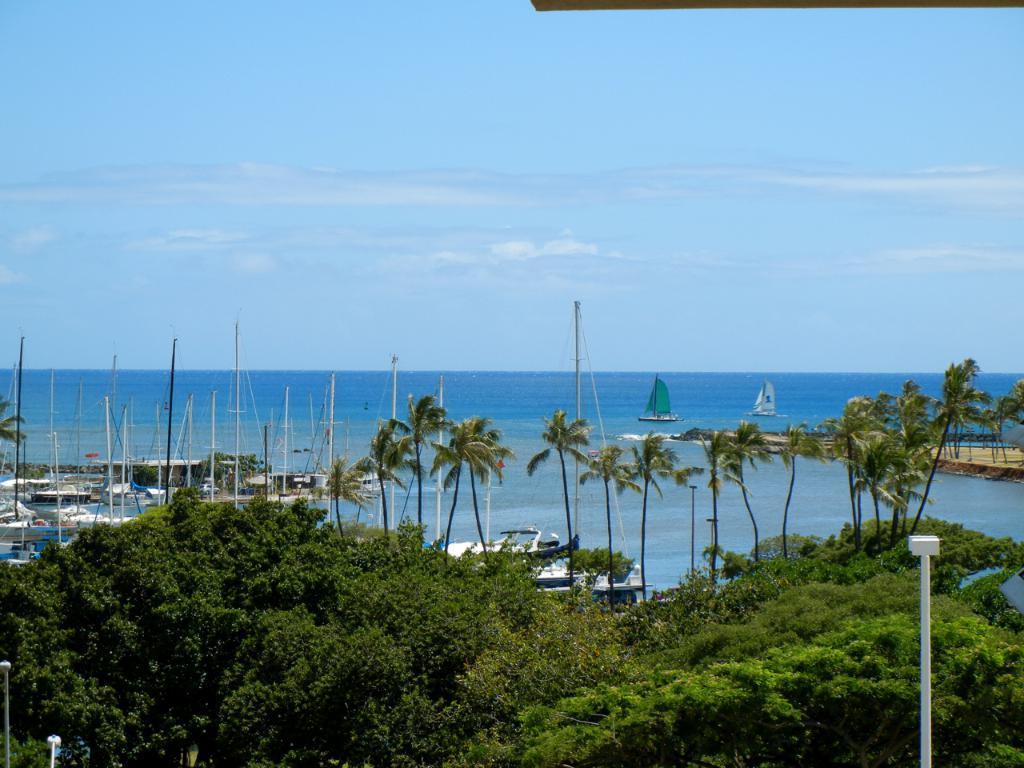Please provide a concise description of this image. In this image I can see few trees and few white colored poles. In the background I can see the water, few boats on the surface of the water, few trees and the sky. 